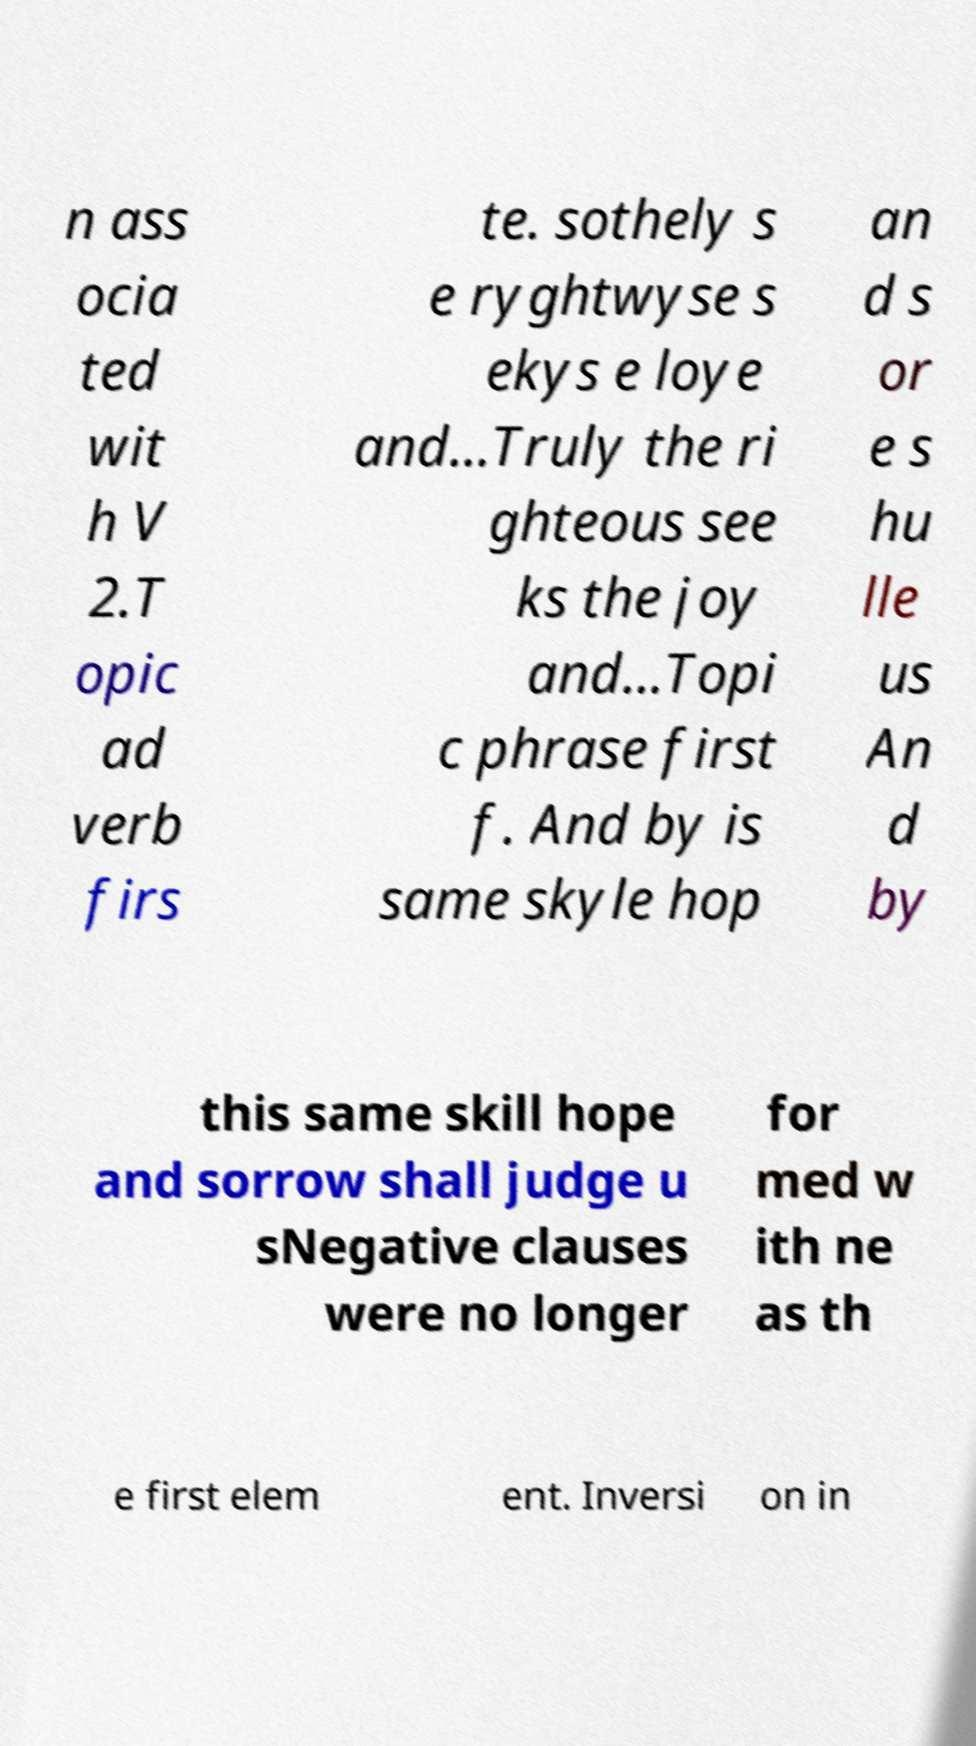There's text embedded in this image that I need extracted. Can you transcribe it verbatim? n ass ocia ted wit h V 2.T opic ad verb firs te. sothely s e ryghtwyse s ekys e loye and...Truly the ri ghteous see ks the joy and...Topi c phrase first f. And by is same skyle hop an d s or e s hu lle us An d by this same skill hope and sorrow shall judge u sNegative clauses were no longer for med w ith ne as th e first elem ent. Inversi on in 